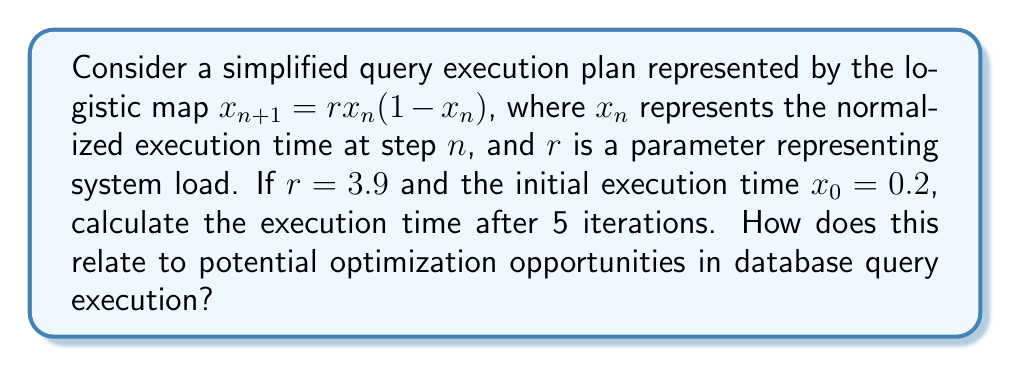Solve this math problem. To solve this problem, we'll iterate the logistic map equation for 5 steps:

1) For $n=0$:
   $x_1 = 3.9 \cdot 0.2 \cdot (1-0.2) = 0.624$

2) For $n=1$:
   $x_2 = 3.9 \cdot 0.624 \cdot (1-0.624) = 0.915624$

3) For $n=2$:
   $x_3 = 3.9 \cdot 0.915624 \cdot (1-0.915624) = 0.300384$

4) For $n=3$:
   $x_4 = 3.9 \cdot 0.300384 \cdot (1-0.300384) = 0.820435$

5) For $n=4$:
   $x_5 = 3.9 \cdot 0.820435 \cdot (1-0.820435) = 0.575872$

The execution time after 5 iterations is approximately 0.575872.

This relates to potential optimization opportunities in database query execution as follows:

1) The chaotic behavior of the logistic map (for $r > 3.57$) mirrors the unpredictable nature of query execution times under high system loads.

2) The sensitivity to initial conditions (a hallmark of chaos theory) suggests that small changes in query structure or system state can lead to significant changes in execution time.

3) The presence of a strange attractor in this system (for $r=3.9$) indicates that execution times, while chaotic, are bounded within a specific range. This could help in setting realistic performance expectations.

4) The irregular oscillations in execution time (0.2 → 0.624 → 0.915624 → 0.300384 → 0.820435 → 0.575872) suggest that query optimization strategies should be adaptive and consider multiple execution scenarios.

5) By identifying patterns in these chaotic execution times, a data analyst could potentially predict performance bottlenecks and suggest targeted optimization strategies, such as query rewriting, index creation, or resource allocation adjustments.
Answer: 0.575872; Chaotic execution times suggest need for adaptive optimization strategies 